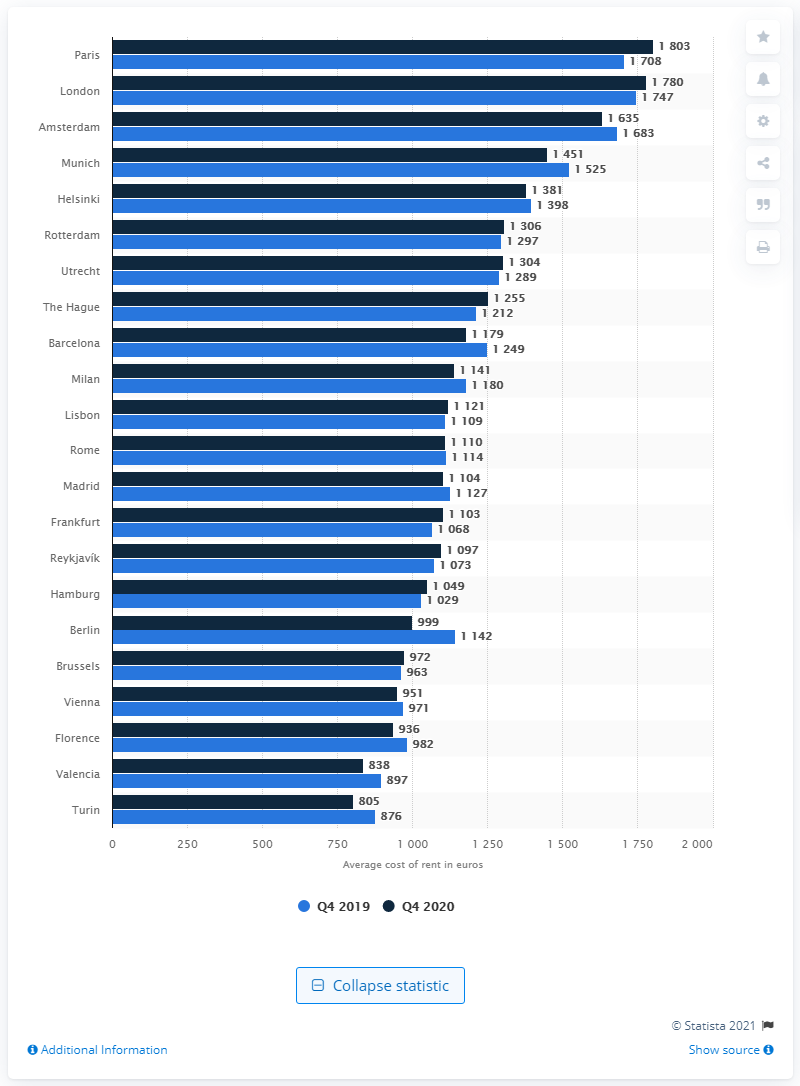List a handful of essential elements in this visual. In the fourth quarter of 2020, it was reported that London was the most expensive city to rent a furnished one-bedroom flat. The city with the highest rent increase between the fourth quarter of 2019 and 2020 was Paris. 